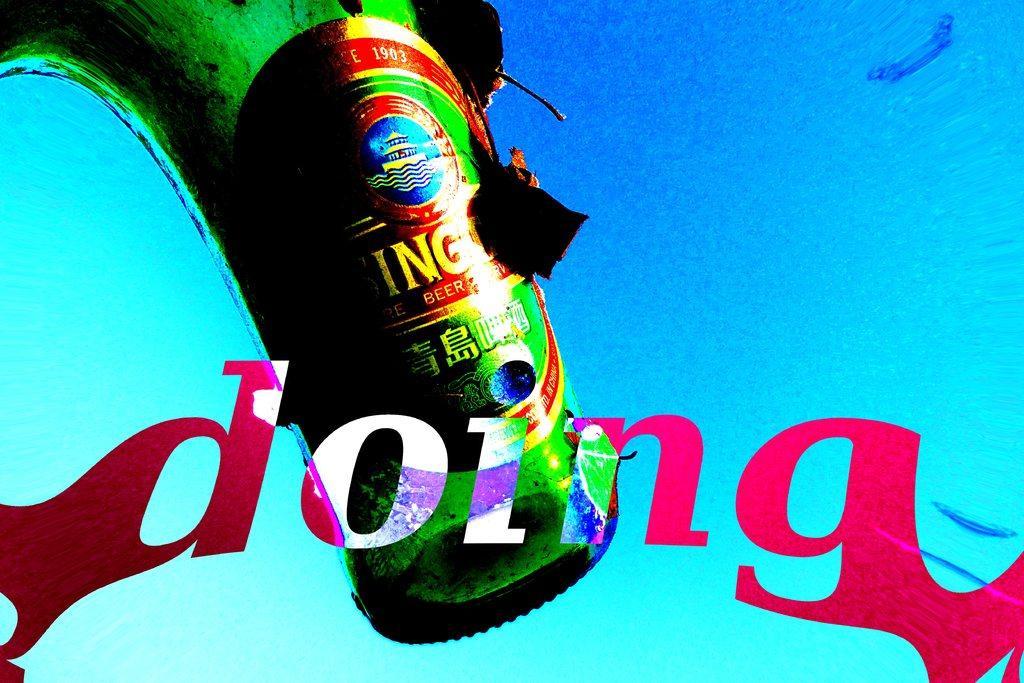Could you give a brief overview of what you see in this image? In this image I can see green colour thing and I can see something is written at few places. I can also see blue colour in background. 